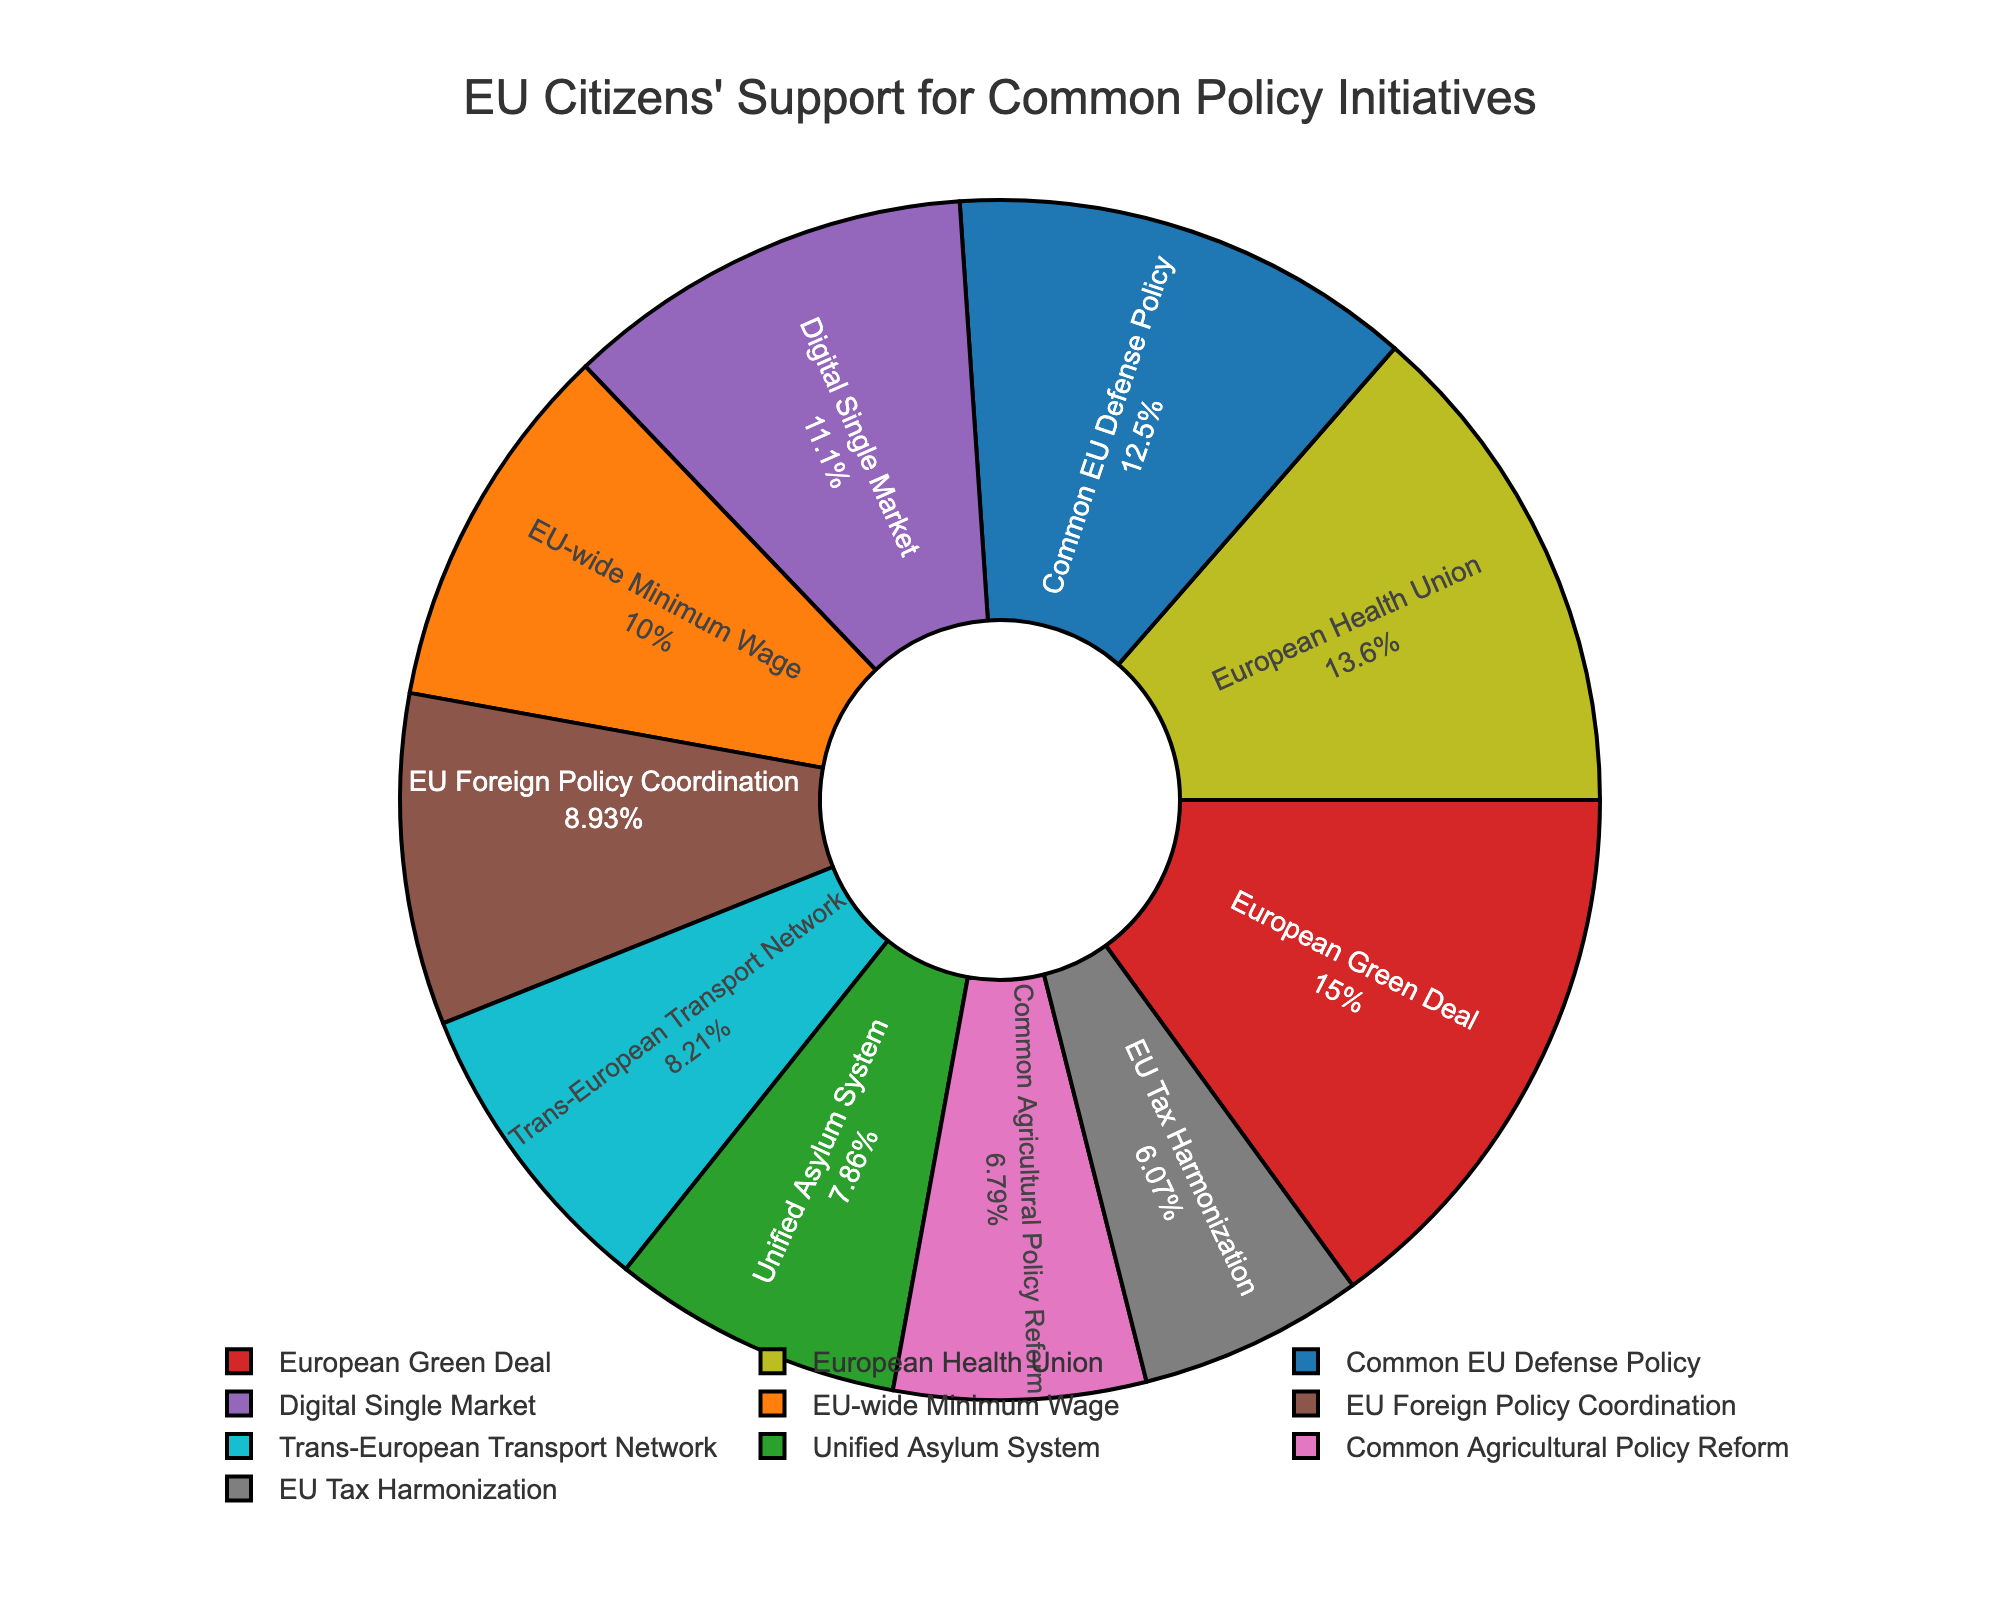What policy initiative has the highest support percentage? By looking at the pie chart, we can identify the segment of the pie that is largest, which visually represents the initiative with the highest support.
Answer: European Green Deal Which initiative has the least support? To find the initiative with the least support, we need to look for the smallest segment of the pie chart.
Answer: EU Tax Harmonization How many initiatives have support percentages over 30%? From the chart, identify all segments with over 30% support. Initiatives with 35%, 38%, 42%, and 31% meet this criterion.
Answer: 4 Compare the support percentages of the Common EU Defense Policy and the European Health Union. Which one is higher and by how much? The Common EU Defense Policy has a support percentage of 35%, and the European Health Union has 38%. The European Health Union's support is higher by 38% - 35% = 3%.
Answer: European Health Union by 3% What is the combined support percentage for the EU Foreign Policy Coordination and the Digital Single Market? Add the support percentages of the two initiatives together: 25% (EU Foreign Policy Coordination) + 31% (Digital Single Market) = 56%.
Answer: 56% How does the support for the EU-wide Minimum Wage compare to that of the Trans-European Transport Network? By comparing the segments, we see that the EU-wide Minimum Wage has 28% support, and the Trans-European Transport Network has 23% support. EU-wide Minimum Wage has 5% more support.
Answer: EU-wide Minimum Wage by 5% What is the average support percentage for all initiatives? Sum the support percentages of all initiatives and divide by the number of initiatives: (35 + 28 + 22 + 42 + 31 + 25 + 19 + 17 + 38 + 23) / 10 = 28%.
Answer: 28% What is the difference in support between the most and least supported initiatives? The most supported initiative is the European Green Deal at 42%, and the least is the EU Tax Harmonization at 17%. The difference is 42% - 17% = 25%.
Answer: 25% Which initiatives have support percentages that are within 3% of each other? Identify pairs of initiatives with support percentages that are within 3% of each other: Common EU Defense Policy (35%) and European Health Union (38%) differ by 3%. EU Foreign Policy Coordination (25%) and Trans-European Transport Network (23%) differ by 2%.
Answer: Common EU Defense Policy and European Health Union; EU Foreign Policy Coordination and Trans-European Transport Network Determine the initiatives that make up more than 50% combined support. Look for combinations of initiatives whose summed support percentages exceed 50%. The European Green Deal (42%) and the Digital Single Market (31%) together sum to 73%.
Answer: European Green Deal and Digital Single Market 